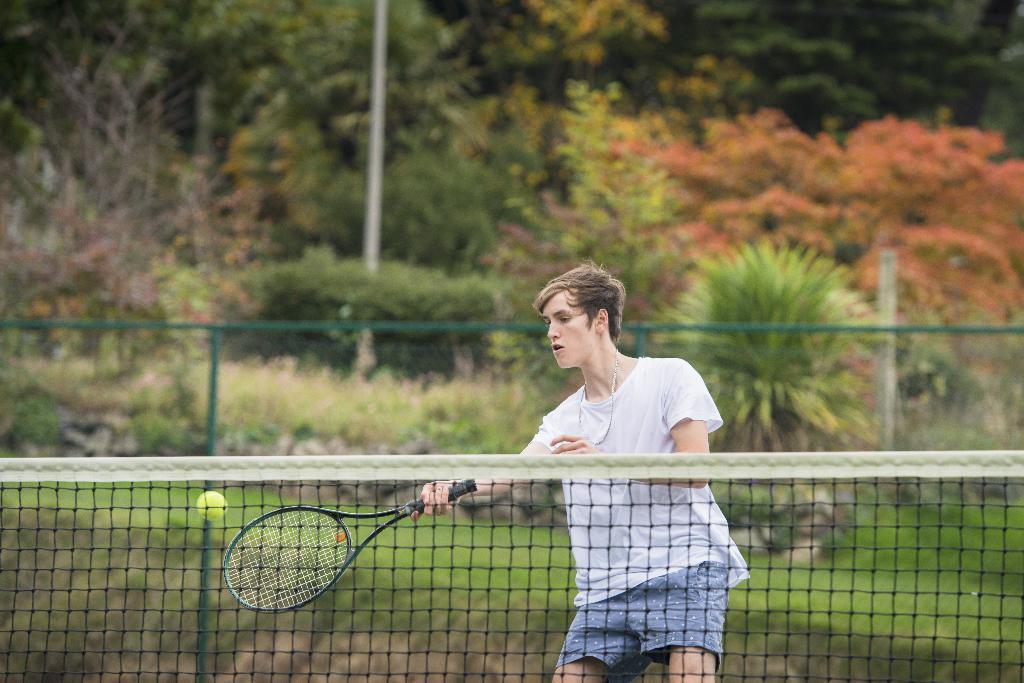Could you give a brief overview of what you see in this image? In this image I see a man who is holding the bat and there is ball over here, I can also see the net over here. In the background I see the fence, plants and the trees. 